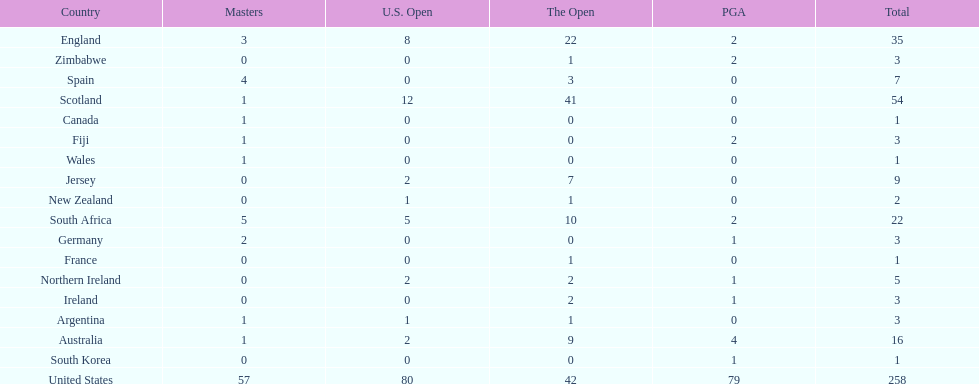How many countries have produced the same number of championship golfers as canada? 3. 